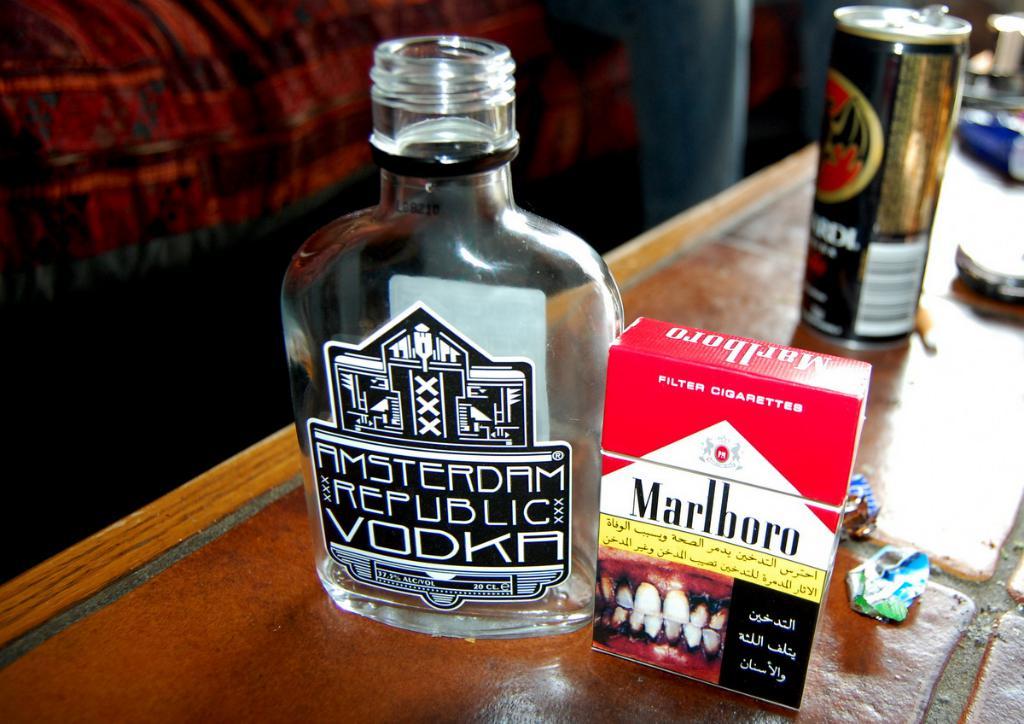What brand of cigarettes?
Keep it short and to the point. Marlboro. 